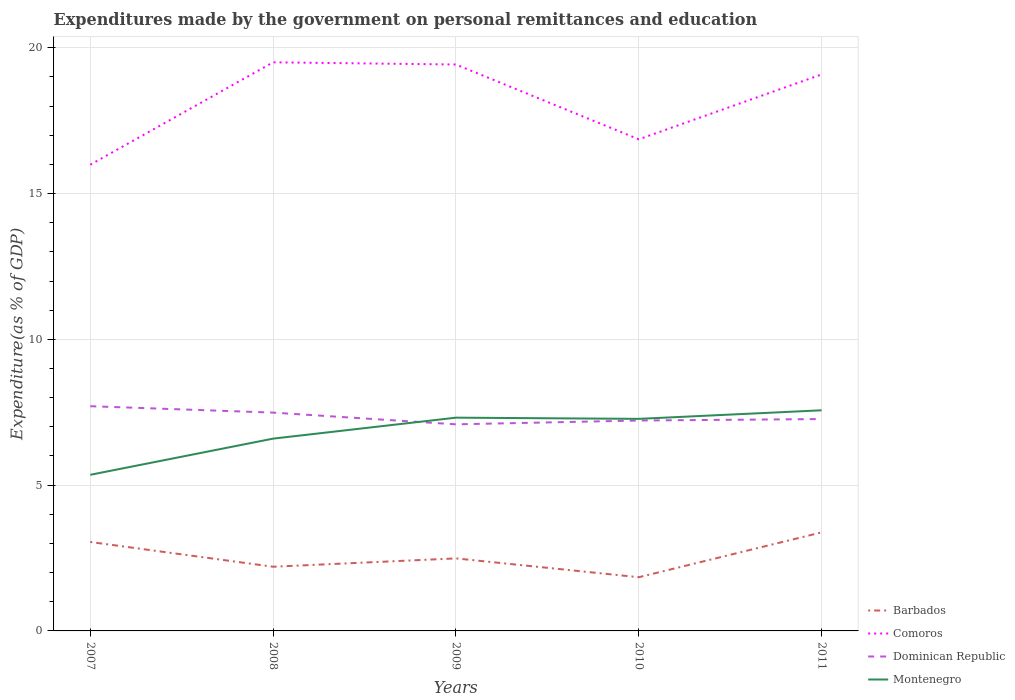Does the line corresponding to Dominican Republic intersect with the line corresponding to Montenegro?
Your answer should be compact. Yes. Is the number of lines equal to the number of legend labels?
Provide a short and direct response. Yes. Across all years, what is the maximum expenditures made by the government on personal remittances and education in Comoros?
Your response must be concise. 15.99. What is the total expenditures made by the government on personal remittances and education in Dominican Republic in the graph?
Your answer should be very brief. 0.4. What is the difference between the highest and the second highest expenditures made by the government on personal remittances and education in Comoros?
Make the answer very short. 3.51. What is the difference between two consecutive major ticks on the Y-axis?
Keep it short and to the point. 5. How many legend labels are there?
Make the answer very short. 4. What is the title of the graph?
Offer a very short reply. Expenditures made by the government on personal remittances and education. Does "Cote d'Ivoire" appear as one of the legend labels in the graph?
Provide a short and direct response. No. What is the label or title of the Y-axis?
Provide a succinct answer. Expenditure(as % of GDP). What is the Expenditure(as % of GDP) in Barbados in 2007?
Give a very brief answer. 3.05. What is the Expenditure(as % of GDP) of Comoros in 2007?
Ensure brevity in your answer.  15.99. What is the Expenditure(as % of GDP) in Dominican Republic in 2007?
Offer a terse response. 7.71. What is the Expenditure(as % of GDP) in Montenegro in 2007?
Make the answer very short. 5.35. What is the Expenditure(as % of GDP) of Barbados in 2008?
Provide a short and direct response. 2.2. What is the Expenditure(as % of GDP) of Comoros in 2008?
Keep it short and to the point. 19.5. What is the Expenditure(as % of GDP) of Dominican Republic in 2008?
Make the answer very short. 7.49. What is the Expenditure(as % of GDP) in Montenegro in 2008?
Make the answer very short. 6.6. What is the Expenditure(as % of GDP) of Barbados in 2009?
Keep it short and to the point. 2.49. What is the Expenditure(as % of GDP) of Comoros in 2009?
Ensure brevity in your answer.  19.43. What is the Expenditure(as % of GDP) in Dominican Republic in 2009?
Offer a very short reply. 7.09. What is the Expenditure(as % of GDP) in Montenegro in 2009?
Keep it short and to the point. 7.31. What is the Expenditure(as % of GDP) in Barbados in 2010?
Provide a short and direct response. 1.84. What is the Expenditure(as % of GDP) of Comoros in 2010?
Ensure brevity in your answer.  16.86. What is the Expenditure(as % of GDP) in Dominican Republic in 2010?
Provide a short and direct response. 7.22. What is the Expenditure(as % of GDP) in Montenegro in 2010?
Ensure brevity in your answer.  7.27. What is the Expenditure(as % of GDP) of Barbados in 2011?
Provide a succinct answer. 3.38. What is the Expenditure(as % of GDP) in Comoros in 2011?
Keep it short and to the point. 19.09. What is the Expenditure(as % of GDP) in Dominican Republic in 2011?
Provide a short and direct response. 7.27. What is the Expenditure(as % of GDP) of Montenegro in 2011?
Provide a short and direct response. 7.57. Across all years, what is the maximum Expenditure(as % of GDP) in Barbados?
Your answer should be very brief. 3.38. Across all years, what is the maximum Expenditure(as % of GDP) in Comoros?
Give a very brief answer. 19.5. Across all years, what is the maximum Expenditure(as % of GDP) of Dominican Republic?
Ensure brevity in your answer.  7.71. Across all years, what is the maximum Expenditure(as % of GDP) of Montenegro?
Your answer should be very brief. 7.57. Across all years, what is the minimum Expenditure(as % of GDP) in Barbados?
Your answer should be compact. 1.84. Across all years, what is the minimum Expenditure(as % of GDP) of Comoros?
Ensure brevity in your answer.  15.99. Across all years, what is the minimum Expenditure(as % of GDP) in Dominican Republic?
Offer a very short reply. 7.09. Across all years, what is the minimum Expenditure(as % of GDP) in Montenegro?
Offer a very short reply. 5.35. What is the total Expenditure(as % of GDP) in Barbados in the graph?
Provide a short and direct response. 12.96. What is the total Expenditure(as % of GDP) in Comoros in the graph?
Provide a succinct answer. 90.87. What is the total Expenditure(as % of GDP) of Dominican Republic in the graph?
Ensure brevity in your answer.  36.76. What is the total Expenditure(as % of GDP) in Montenegro in the graph?
Offer a terse response. 34.1. What is the difference between the Expenditure(as % of GDP) in Barbados in 2007 and that in 2008?
Offer a terse response. 0.85. What is the difference between the Expenditure(as % of GDP) of Comoros in 2007 and that in 2008?
Your answer should be very brief. -3.51. What is the difference between the Expenditure(as % of GDP) in Dominican Republic in 2007 and that in 2008?
Offer a very short reply. 0.22. What is the difference between the Expenditure(as % of GDP) of Montenegro in 2007 and that in 2008?
Ensure brevity in your answer.  -1.24. What is the difference between the Expenditure(as % of GDP) in Barbados in 2007 and that in 2009?
Offer a very short reply. 0.56. What is the difference between the Expenditure(as % of GDP) in Comoros in 2007 and that in 2009?
Provide a short and direct response. -3.44. What is the difference between the Expenditure(as % of GDP) of Dominican Republic in 2007 and that in 2009?
Your response must be concise. 0.62. What is the difference between the Expenditure(as % of GDP) in Montenegro in 2007 and that in 2009?
Provide a succinct answer. -1.96. What is the difference between the Expenditure(as % of GDP) in Barbados in 2007 and that in 2010?
Provide a short and direct response. 1.21. What is the difference between the Expenditure(as % of GDP) of Comoros in 2007 and that in 2010?
Offer a terse response. -0.87. What is the difference between the Expenditure(as % of GDP) in Dominican Republic in 2007 and that in 2010?
Make the answer very short. 0.49. What is the difference between the Expenditure(as % of GDP) of Montenegro in 2007 and that in 2010?
Ensure brevity in your answer.  -1.92. What is the difference between the Expenditure(as % of GDP) in Barbados in 2007 and that in 2011?
Provide a succinct answer. -0.33. What is the difference between the Expenditure(as % of GDP) of Comoros in 2007 and that in 2011?
Provide a short and direct response. -3.1. What is the difference between the Expenditure(as % of GDP) in Dominican Republic in 2007 and that in 2011?
Your answer should be compact. 0.44. What is the difference between the Expenditure(as % of GDP) of Montenegro in 2007 and that in 2011?
Ensure brevity in your answer.  -2.21. What is the difference between the Expenditure(as % of GDP) in Barbados in 2008 and that in 2009?
Keep it short and to the point. -0.29. What is the difference between the Expenditure(as % of GDP) in Comoros in 2008 and that in 2009?
Your response must be concise. 0.08. What is the difference between the Expenditure(as % of GDP) of Dominican Republic in 2008 and that in 2009?
Give a very brief answer. 0.4. What is the difference between the Expenditure(as % of GDP) in Montenegro in 2008 and that in 2009?
Offer a very short reply. -0.72. What is the difference between the Expenditure(as % of GDP) of Barbados in 2008 and that in 2010?
Your response must be concise. 0.36. What is the difference between the Expenditure(as % of GDP) of Comoros in 2008 and that in 2010?
Keep it short and to the point. 2.64. What is the difference between the Expenditure(as % of GDP) in Dominican Republic in 2008 and that in 2010?
Keep it short and to the point. 0.27. What is the difference between the Expenditure(as % of GDP) of Montenegro in 2008 and that in 2010?
Keep it short and to the point. -0.68. What is the difference between the Expenditure(as % of GDP) of Barbados in 2008 and that in 2011?
Your answer should be very brief. -1.18. What is the difference between the Expenditure(as % of GDP) of Comoros in 2008 and that in 2011?
Your answer should be very brief. 0.42. What is the difference between the Expenditure(as % of GDP) of Dominican Republic in 2008 and that in 2011?
Ensure brevity in your answer.  0.22. What is the difference between the Expenditure(as % of GDP) in Montenegro in 2008 and that in 2011?
Keep it short and to the point. -0.97. What is the difference between the Expenditure(as % of GDP) of Barbados in 2009 and that in 2010?
Provide a short and direct response. 0.65. What is the difference between the Expenditure(as % of GDP) in Comoros in 2009 and that in 2010?
Provide a succinct answer. 2.57. What is the difference between the Expenditure(as % of GDP) of Dominican Republic in 2009 and that in 2010?
Your response must be concise. -0.13. What is the difference between the Expenditure(as % of GDP) in Montenegro in 2009 and that in 2010?
Your answer should be compact. 0.04. What is the difference between the Expenditure(as % of GDP) of Barbados in 2009 and that in 2011?
Give a very brief answer. -0.89. What is the difference between the Expenditure(as % of GDP) in Comoros in 2009 and that in 2011?
Your response must be concise. 0.34. What is the difference between the Expenditure(as % of GDP) of Dominican Republic in 2009 and that in 2011?
Provide a short and direct response. -0.18. What is the difference between the Expenditure(as % of GDP) of Montenegro in 2009 and that in 2011?
Your answer should be very brief. -0.25. What is the difference between the Expenditure(as % of GDP) of Barbados in 2010 and that in 2011?
Provide a short and direct response. -1.54. What is the difference between the Expenditure(as % of GDP) of Comoros in 2010 and that in 2011?
Make the answer very short. -2.22. What is the difference between the Expenditure(as % of GDP) of Montenegro in 2010 and that in 2011?
Your response must be concise. -0.29. What is the difference between the Expenditure(as % of GDP) in Barbados in 2007 and the Expenditure(as % of GDP) in Comoros in 2008?
Offer a terse response. -16.45. What is the difference between the Expenditure(as % of GDP) in Barbados in 2007 and the Expenditure(as % of GDP) in Dominican Republic in 2008?
Offer a terse response. -4.44. What is the difference between the Expenditure(as % of GDP) in Barbados in 2007 and the Expenditure(as % of GDP) in Montenegro in 2008?
Offer a very short reply. -3.54. What is the difference between the Expenditure(as % of GDP) of Comoros in 2007 and the Expenditure(as % of GDP) of Dominican Republic in 2008?
Your answer should be compact. 8.5. What is the difference between the Expenditure(as % of GDP) in Comoros in 2007 and the Expenditure(as % of GDP) in Montenegro in 2008?
Make the answer very short. 9.39. What is the difference between the Expenditure(as % of GDP) of Dominican Republic in 2007 and the Expenditure(as % of GDP) of Montenegro in 2008?
Provide a succinct answer. 1.11. What is the difference between the Expenditure(as % of GDP) of Barbados in 2007 and the Expenditure(as % of GDP) of Comoros in 2009?
Make the answer very short. -16.38. What is the difference between the Expenditure(as % of GDP) in Barbados in 2007 and the Expenditure(as % of GDP) in Dominican Republic in 2009?
Keep it short and to the point. -4.03. What is the difference between the Expenditure(as % of GDP) in Barbados in 2007 and the Expenditure(as % of GDP) in Montenegro in 2009?
Ensure brevity in your answer.  -4.26. What is the difference between the Expenditure(as % of GDP) of Comoros in 2007 and the Expenditure(as % of GDP) of Dominican Republic in 2009?
Provide a succinct answer. 8.9. What is the difference between the Expenditure(as % of GDP) of Comoros in 2007 and the Expenditure(as % of GDP) of Montenegro in 2009?
Give a very brief answer. 8.68. What is the difference between the Expenditure(as % of GDP) of Dominican Republic in 2007 and the Expenditure(as % of GDP) of Montenegro in 2009?
Your answer should be very brief. 0.39. What is the difference between the Expenditure(as % of GDP) of Barbados in 2007 and the Expenditure(as % of GDP) of Comoros in 2010?
Your answer should be compact. -13.81. What is the difference between the Expenditure(as % of GDP) in Barbados in 2007 and the Expenditure(as % of GDP) in Dominican Republic in 2010?
Keep it short and to the point. -4.17. What is the difference between the Expenditure(as % of GDP) in Barbados in 2007 and the Expenditure(as % of GDP) in Montenegro in 2010?
Provide a short and direct response. -4.22. What is the difference between the Expenditure(as % of GDP) of Comoros in 2007 and the Expenditure(as % of GDP) of Dominican Republic in 2010?
Your answer should be very brief. 8.77. What is the difference between the Expenditure(as % of GDP) of Comoros in 2007 and the Expenditure(as % of GDP) of Montenegro in 2010?
Make the answer very short. 8.72. What is the difference between the Expenditure(as % of GDP) in Dominican Republic in 2007 and the Expenditure(as % of GDP) in Montenegro in 2010?
Make the answer very short. 0.43. What is the difference between the Expenditure(as % of GDP) of Barbados in 2007 and the Expenditure(as % of GDP) of Comoros in 2011?
Offer a terse response. -16.04. What is the difference between the Expenditure(as % of GDP) of Barbados in 2007 and the Expenditure(as % of GDP) of Dominican Republic in 2011?
Make the answer very short. -4.22. What is the difference between the Expenditure(as % of GDP) in Barbados in 2007 and the Expenditure(as % of GDP) in Montenegro in 2011?
Your answer should be compact. -4.52. What is the difference between the Expenditure(as % of GDP) in Comoros in 2007 and the Expenditure(as % of GDP) in Dominican Republic in 2011?
Your response must be concise. 8.72. What is the difference between the Expenditure(as % of GDP) of Comoros in 2007 and the Expenditure(as % of GDP) of Montenegro in 2011?
Offer a very short reply. 8.42. What is the difference between the Expenditure(as % of GDP) of Dominican Republic in 2007 and the Expenditure(as % of GDP) of Montenegro in 2011?
Keep it short and to the point. 0.14. What is the difference between the Expenditure(as % of GDP) of Barbados in 2008 and the Expenditure(as % of GDP) of Comoros in 2009?
Your answer should be very brief. -17.22. What is the difference between the Expenditure(as % of GDP) in Barbados in 2008 and the Expenditure(as % of GDP) in Dominican Republic in 2009?
Give a very brief answer. -4.88. What is the difference between the Expenditure(as % of GDP) in Barbados in 2008 and the Expenditure(as % of GDP) in Montenegro in 2009?
Your answer should be compact. -5.11. What is the difference between the Expenditure(as % of GDP) in Comoros in 2008 and the Expenditure(as % of GDP) in Dominican Republic in 2009?
Offer a very short reply. 12.42. What is the difference between the Expenditure(as % of GDP) in Comoros in 2008 and the Expenditure(as % of GDP) in Montenegro in 2009?
Offer a terse response. 12.19. What is the difference between the Expenditure(as % of GDP) in Dominican Republic in 2008 and the Expenditure(as % of GDP) in Montenegro in 2009?
Offer a very short reply. 0.17. What is the difference between the Expenditure(as % of GDP) of Barbados in 2008 and the Expenditure(as % of GDP) of Comoros in 2010?
Give a very brief answer. -14.66. What is the difference between the Expenditure(as % of GDP) of Barbados in 2008 and the Expenditure(as % of GDP) of Dominican Republic in 2010?
Offer a terse response. -5.01. What is the difference between the Expenditure(as % of GDP) in Barbados in 2008 and the Expenditure(as % of GDP) in Montenegro in 2010?
Provide a succinct answer. -5.07. What is the difference between the Expenditure(as % of GDP) in Comoros in 2008 and the Expenditure(as % of GDP) in Dominican Republic in 2010?
Make the answer very short. 12.29. What is the difference between the Expenditure(as % of GDP) of Comoros in 2008 and the Expenditure(as % of GDP) of Montenegro in 2010?
Provide a succinct answer. 12.23. What is the difference between the Expenditure(as % of GDP) in Dominican Republic in 2008 and the Expenditure(as % of GDP) in Montenegro in 2010?
Keep it short and to the point. 0.21. What is the difference between the Expenditure(as % of GDP) in Barbados in 2008 and the Expenditure(as % of GDP) in Comoros in 2011?
Provide a short and direct response. -16.88. What is the difference between the Expenditure(as % of GDP) in Barbados in 2008 and the Expenditure(as % of GDP) in Dominican Republic in 2011?
Ensure brevity in your answer.  -5.06. What is the difference between the Expenditure(as % of GDP) of Barbados in 2008 and the Expenditure(as % of GDP) of Montenegro in 2011?
Ensure brevity in your answer.  -5.37. What is the difference between the Expenditure(as % of GDP) of Comoros in 2008 and the Expenditure(as % of GDP) of Dominican Republic in 2011?
Your answer should be very brief. 12.24. What is the difference between the Expenditure(as % of GDP) in Comoros in 2008 and the Expenditure(as % of GDP) in Montenegro in 2011?
Provide a short and direct response. 11.94. What is the difference between the Expenditure(as % of GDP) in Dominican Republic in 2008 and the Expenditure(as % of GDP) in Montenegro in 2011?
Make the answer very short. -0.08. What is the difference between the Expenditure(as % of GDP) of Barbados in 2009 and the Expenditure(as % of GDP) of Comoros in 2010?
Your answer should be very brief. -14.37. What is the difference between the Expenditure(as % of GDP) of Barbados in 2009 and the Expenditure(as % of GDP) of Dominican Republic in 2010?
Your response must be concise. -4.73. What is the difference between the Expenditure(as % of GDP) in Barbados in 2009 and the Expenditure(as % of GDP) in Montenegro in 2010?
Provide a short and direct response. -4.79. What is the difference between the Expenditure(as % of GDP) of Comoros in 2009 and the Expenditure(as % of GDP) of Dominican Republic in 2010?
Ensure brevity in your answer.  12.21. What is the difference between the Expenditure(as % of GDP) in Comoros in 2009 and the Expenditure(as % of GDP) in Montenegro in 2010?
Your answer should be compact. 12.15. What is the difference between the Expenditure(as % of GDP) of Dominican Republic in 2009 and the Expenditure(as % of GDP) of Montenegro in 2010?
Offer a very short reply. -0.19. What is the difference between the Expenditure(as % of GDP) in Barbados in 2009 and the Expenditure(as % of GDP) in Comoros in 2011?
Ensure brevity in your answer.  -16.6. What is the difference between the Expenditure(as % of GDP) of Barbados in 2009 and the Expenditure(as % of GDP) of Dominican Republic in 2011?
Ensure brevity in your answer.  -4.78. What is the difference between the Expenditure(as % of GDP) in Barbados in 2009 and the Expenditure(as % of GDP) in Montenegro in 2011?
Make the answer very short. -5.08. What is the difference between the Expenditure(as % of GDP) of Comoros in 2009 and the Expenditure(as % of GDP) of Dominican Republic in 2011?
Make the answer very short. 12.16. What is the difference between the Expenditure(as % of GDP) of Comoros in 2009 and the Expenditure(as % of GDP) of Montenegro in 2011?
Ensure brevity in your answer.  11.86. What is the difference between the Expenditure(as % of GDP) of Dominican Republic in 2009 and the Expenditure(as % of GDP) of Montenegro in 2011?
Your response must be concise. -0.48. What is the difference between the Expenditure(as % of GDP) of Barbados in 2010 and the Expenditure(as % of GDP) of Comoros in 2011?
Provide a succinct answer. -17.24. What is the difference between the Expenditure(as % of GDP) in Barbados in 2010 and the Expenditure(as % of GDP) in Dominican Republic in 2011?
Your answer should be very brief. -5.42. What is the difference between the Expenditure(as % of GDP) in Barbados in 2010 and the Expenditure(as % of GDP) in Montenegro in 2011?
Offer a terse response. -5.73. What is the difference between the Expenditure(as % of GDP) of Comoros in 2010 and the Expenditure(as % of GDP) of Dominican Republic in 2011?
Offer a very short reply. 9.6. What is the difference between the Expenditure(as % of GDP) in Comoros in 2010 and the Expenditure(as % of GDP) in Montenegro in 2011?
Offer a very short reply. 9.29. What is the difference between the Expenditure(as % of GDP) in Dominican Republic in 2010 and the Expenditure(as % of GDP) in Montenegro in 2011?
Offer a very short reply. -0.35. What is the average Expenditure(as % of GDP) in Barbados per year?
Keep it short and to the point. 2.59. What is the average Expenditure(as % of GDP) in Comoros per year?
Give a very brief answer. 18.17. What is the average Expenditure(as % of GDP) in Dominican Republic per year?
Give a very brief answer. 7.35. What is the average Expenditure(as % of GDP) of Montenegro per year?
Give a very brief answer. 6.82. In the year 2007, what is the difference between the Expenditure(as % of GDP) of Barbados and Expenditure(as % of GDP) of Comoros?
Keep it short and to the point. -12.94. In the year 2007, what is the difference between the Expenditure(as % of GDP) of Barbados and Expenditure(as % of GDP) of Dominican Republic?
Your response must be concise. -4.66. In the year 2007, what is the difference between the Expenditure(as % of GDP) of Barbados and Expenditure(as % of GDP) of Montenegro?
Offer a terse response. -2.3. In the year 2007, what is the difference between the Expenditure(as % of GDP) of Comoros and Expenditure(as % of GDP) of Dominican Republic?
Keep it short and to the point. 8.28. In the year 2007, what is the difference between the Expenditure(as % of GDP) in Comoros and Expenditure(as % of GDP) in Montenegro?
Your response must be concise. 10.64. In the year 2007, what is the difference between the Expenditure(as % of GDP) in Dominican Republic and Expenditure(as % of GDP) in Montenegro?
Offer a terse response. 2.35. In the year 2008, what is the difference between the Expenditure(as % of GDP) of Barbados and Expenditure(as % of GDP) of Comoros?
Your response must be concise. -17.3. In the year 2008, what is the difference between the Expenditure(as % of GDP) in Barbados and Expenditure(as % of GDP) in Dominican Republic?
Your answer should be compact. -5.29. In the year 2008, what is the difference between the Expenditure(as % of GDP) in Barbados and Expenditure(as % of GDP) in Montenegro?
Provide a short and direct response. -4.39. In the year 2008, what is the difference between the Expenditure(as % of GDP) of Comoros and Expenditure(as % of GDP) of Dominican Republic?
Your answer should be compact. 12.01. In the year 2008, what is the difference between the Expenditure(as % of GDP) of Comoros and Expenditure(as % of GDP) of Montenegro?
Make the answer very short. 12.91. In the year 2008, what is the difference between the Expenditure(as % of GDP) of Dominican Republic and Expenditure(as % of GDP) of Montenegro?
Your answer should be compact. 0.89. In the year 2009, what is the difference between the Expenditure(as % of GDP) in Barbados and Expenditure(as % of GDP) in Comoros?
Keep it short and to the point. -16.94. In the year 2009, what is the difference between the Expenditure(as % of GDP) of Barbados and Expenditure(as % of GDP) of Dominican Republic?
Provide a succinct answer. -4.6. In the year 2009, what is the difference between the Expenditure(as % of GDP) in Barbados and Expenditure(as % of GDP) in Montenegro?
Ensure brevity in your answer.  -4.83. In the year 2009, what is the difference between the Expenditure(as % of GDP) in Comoros and Expenditure(as % of GDP) in Dominican Republic?
Give a very brief answer. 12.34. In the year 2009, what is the difference between the Expenditure(as % of GDP) of Comoros and Expenditure(as % of GDP) of Montenegro?
Ensure brevity in your answer.  12.11. In the year 2009, what is the difference between the Expenditure(as % of GDP) of Dominican Republic and Expenditure(as % of GDP) of Montenegro?
Offer a terse response. -0.23. In the year 2010, what is the difference between the Expenditure(as % of GDP) in Barbados and Expenditure(as % of GDP) in Comoros?
Your response must be concise. -15.02. In the year 2010, what is the difference between the Expenditure(as % of GDP) in Barbados and Expenditure(as % of GDP) in Dominican Republic?
Keep it short and to the point. -5.37. In the year 2010, what is the difference between the Expenditure(as % of GDP) in Barbados and Expenditure(as % of GDP) in Montenegro?
Ensure brevity in your answer.  -5.43. In the year 2010, what is the difference between the Expenditure(as % of GDP) of Comoros and Expenditure(as % of GDP) of Dominican Republic?
Your answer should be compact. 9.65. In the year 2010, what is the difference between the Expenditure(as % of GDP) of Comoros and Expenditure(as % of GDP) of Montenegro?
Your response must be concise. 9.59. In the year 2010, what is the difference between the Expenditure(as % of GDP) of Dominican Republic and Expenditure(as % of GDP) of Montenegro?
Make the answer very short. -0.06. In the year 2011, what is the difference between the Expenditure(as % of GDP) in Barbados and Expenditure(as % of GDP) in Comoros?
Offer a very short reply. -15.71. In the year 2011, what is the difference between the Expenditure(as % of GDP) of Barbados and Expenditure(as % of GDP) of Dominican Republic?
Ensure brevity in your answer.  -3.89. In the year 2011, what is the difference between the Expenditure(as % of GDP) of Barbados and Expenditure(as % of GDP) of Montenegro?
Your answer should be very brief. -4.19. In the year 2011, what is the difference between the Expenditure(as % of GDP) in Comoros and Expenditure(as % of GDP) in Dominican Republic?
Your answer should be very brief. 11.82. In the year 2011, what is the difference between the Expenditure(as % of GDP) in Comoros and Expenditure(as % of GDP) in Montenegro?
Offer a terse response. 11.52. In the year 2011, what is the difference between the Expenditure(as % of GDP) in Dominican Republic and Expenditure(as % of GDP) in Montenegro?
Keep it short and to the point. -0.3. What is the ratio of the Expenditure(as % of GDP) of Barbados in 2007 to that in 2008?
Offer a very short reply. 1.39. What is the ratio of the Expenditure(as % of GDP) of Comoros in 2007 to that in 2008?
Make the answer very short. 0.82. What is the ratio of the Expenditure(as % of GDP) of Dominican Republic in 2007 to that in 2008?
Your answer should be compact. 1.03. What is the ratio of the Expenditure(as % of GDP) in Montenegro in 2007 to that in 2008?
Offer a very short reply. 0.81. What is the ratio of the Expenditure(as % of GDP) in Barbados in 2007 to that in 2009?
Keep it short and to the point. 1.23. What is the ratio of the Expenditure(as % of GDP) in Comoros in 2007 to that in 2009?
Your answer should be very brief. 0.82. What is the ratio of the Expenditure(as % of GDP) in Dominican Republic in 2007 to that in 2009?
Provide a short and direct response. 1.09. What is the ratio of the Expenditure(as % of GDP) of Montenegro in 2007 to that in 2009?
Your answer should be very brief. 0.73. What is the ratio of the Expenditure(as % of GDP) in Barbados in 2007 to that in 2010?
Your answer should be compact. 1.66. What is the ratio of the Expenditure(as % of GDP) in Comoros in 2007 to that in 2010?
Provide a short and direct response. 0.95. What is the ratio of the Expenditure(as % of GDP) in Dominican Republic in 2007 to that in 2010?
Provide a short and direct response. 1.07. What is the ratio of the Expenditure(as % of GDP) of Montenegro in 2007 to that in 2010?
Offer a very short reply. 0.74. What is the ratio of the Expenditure(as % of GDP) in Barbados in 2007 to that in 2011?
Your answer should be compact. 0.9. What is the ratio of the Expenditure(as % of GDP) of Comoros in 2007 to that in 2011?
Your response must be concise. 0.84. What is the ratio of the Expenditure(as % of GDP) in Dominican Republic in 2007 to that in 2011?
Offer a very short reply. 1.06. What is the ratio of the Expenditure(as % of GDP) of Montenegro in 2007 to that in 2011?
Your answer should be very brief. 0.71. What is the ratio of the Expenditure(as % of GDP) in Barbados in 2008 to that in 2009?
Provide a short and direct response. 0.89. What is the ratio of the Expenditure(as % of GDP) of Dominican Republic in 2008 to that in 2009?
Make the answer very short. 1.06. What is the ratio of the Expenditure(as % of GDP) in Montenegro in 2008 to that in 2009?
Your answer should be very brief. 0.9. What is the ratio of the Expenditure(as % of GDP) of Barbados in 2008 to that in 2010?
Keep it short and to the point. 1.2. What is the ratio of the Expenditure(as % of GDP) of Comoros in 2008 to that in 2010?
Your answer should be compact. 1.16. What is the ratio of the Expenditure(as % of GDP) in Dominican Republic in 2008 to that in 2010?
Your response must be concise. 1.04. What is the ratio of the Expenditure(as % of GDP) in Montenegro in 2008 to that in 2010?
Ensure brevity in your answer.  0.91. What is the ratio of the Expenditure(as % of GDP) of Barbados in 2008 to that in 2011?
Provide a short and direct response. 0.65. What is the ratio of the Expenditure(as % of GDP) of Comoros in 2008 to that in 2011?
Keep it short and to the point. 1.02. What is the ratio of the Expenditure(as % of GDP) in Dominican Republic in 2008 to that in 2011?
Give a very brief answer. 1.03. What is the ratio of the Expenditure(as % of GDP) in Montenegro in 2008 to that in 2011?
Keep it short and to the point. 0.87. What is the ratio of the Expenditure(as % of GDP) of Barbados in 2009 to that in 2010?
Ensure brevity in your answer.  1.35. What is the ratio of the Expenditure(as % of GDP) in Comoros in 2009 to that in 2010?
Your answer should be compact. 1.15. What is the ratio of the Expenditure(as % of GDP) of Dominican Republic in 2009 to that in 2010?
Provide a short and direct response. 0.98. What is the ratio of the Expenditure(as % of GDP) in Montenegro in 2009 to that in 2010?
Offer a very short reply. 1.01. What is the ratio of the Expenditure(as % of GDP) of Barbados in 2009 to that in 2011?
Keep it short and to the point. 0.74. What is the ratio of the Expenditure(as % of GDP) in Comoros in 2009 to that in 2011?
Your answer should be very brief. 1.02. What is the ratio of the Expenditure(as % of GDP) in Dominican Republic in 2009 to that in 2011?
Provide a short and direct response. 0.98. What is the ratio of the Expenditure(as % of GDP) in Montenegro in 2009 to that in 2011?
Offer a very short reply. 0.97. What is the ratio of the Expenditure(as % of GDP) of Barbados in 2010 to that in 2011?
Ensure brevity in your answer.  0.54. What is the ratio of the Expenditure(as % of GDP) in Comoros in 2010 to that in 2011?
Keep it short and to the point. 0.88. What is the ratio of the Expenditure(as % of GDP) of Montenegro in 2010 to that in 2011?
Offer a terse response. 0.96. What is the difference between the highest and the second highest Expenditure(as % of GDP) of Barbados?
Offer a terse response. 0.33. What is the difference between the highest and the second highest Expenditure(as % of GDP) of Comoros?
Give a very brief answer. 0.08. What is the difference between the highest and the second highest Expenditure(as % of GDP) in Dominican Republic?
Make the answer very short. 0.22. What is the difference between the highest and the second highest Expenditure(as % of GDP) of Montenegro?
Provide a succinct answer. 0.25. What is the difference between the highest and the lowest Expenditure(as % of GDP) of Barbados?
Your answer should be compact. 1.54. What is the difference between the highest and the lowest Expenditure(as % of GDP) in Comoros?
Give a very brief answer. 3.51. What is the difference between the highest and the lowest Expenditure(as % of GDP) of Dominican Republic?
Give a very brief answer. 0.62. What is the difference between the highest and the lowest Expenditure(as % of GDP) in Montenegro?
Ensure brevity in your answer.  2.21. 